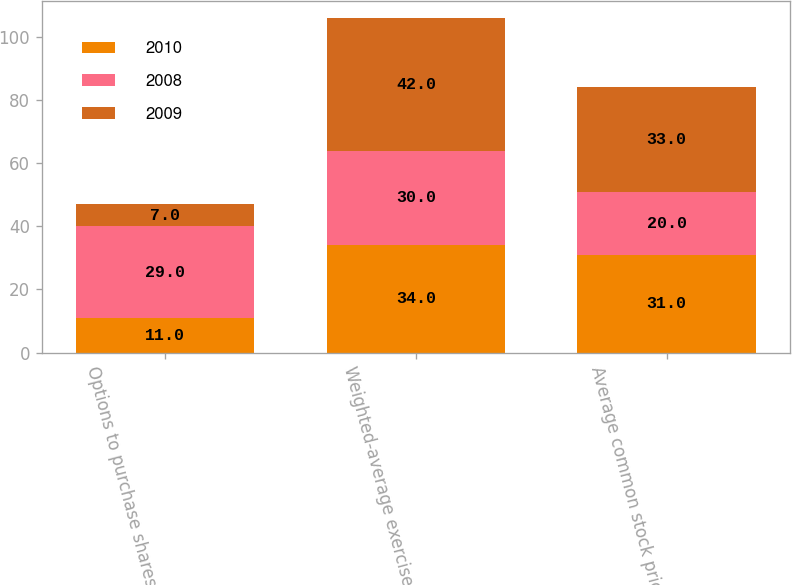Convert chart to OTSL. <chart><loc_0><loc_0><loc_500><loc_500><stacked_bar_chart><ecel><fcel>Options to purchase shares of<fcel>Weighted-average exercise<fcel>Average common stock price<nl><fcel>2010<fcel>11<fcel>34<fcel>31<nl><fcel>2008<fcel>29<fcel>30<fcel>20<nl><fcel>2009<fcel>7<fcel>42<fcel>33<nl></chart> 